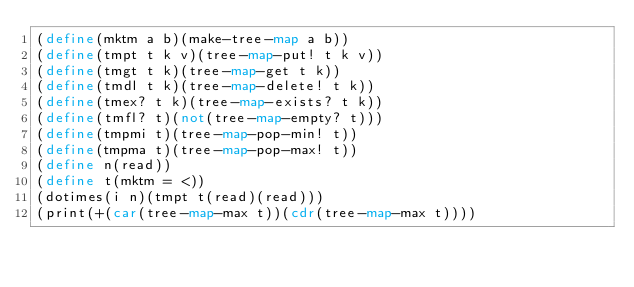<code> <loc_0><loc_0><loc_500><loc_500><_Scheme_>(define(mktm a b)(make-tree-map a b))
(define(tmpt t k v)(tree-map-put! t k v))
(define(tmgt t k)(tree-map-get t k))
(define(tmdl t k)(tree-map-delete! t k))
(define(tmex? t k)(tree-map-exists? t k))
(define(tmfl? t)(not(tree-map-empty? t)))
(define(tmpmi t)(tree-map-pop-min! t))
(define(tmpma t)(tree-map-pop-max! t))
(define n(read))
(define t(mktm = <))
(dotimes(i n)(tmpt t(read)(read)))
(print(+(car(tree-map-max t))(cdr(tree-map-max t))))</code> 